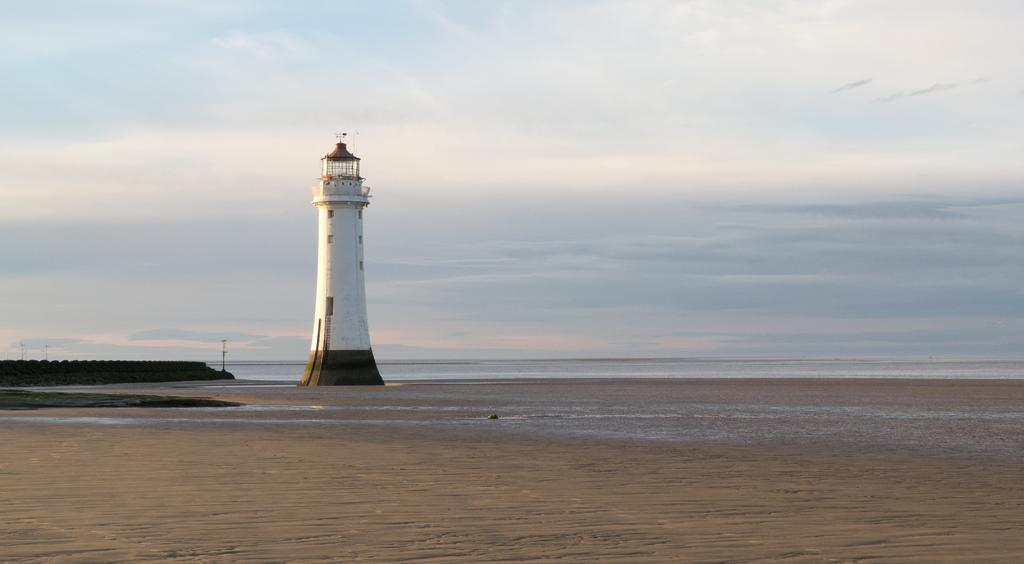What is the main subject of the picture? The main subject of the picture is a lighthouse. Can you describe the appearance of the lighthouse? The lighthouse is white. What type of terrain is visible on the left side of the image? There is sand on the left side of the image. What body of water is visible on the right side of the image? There is an ocean on the right side of the image. How would you describe the weather in the image? The sky is clear, suggesting good weather. Reasoning: Let's think step by step to produce the conversation. We start by mentioning the main subject of the image, which is the lighthouse. Then, we describe its appearance, focusing on the color. Next, we identify the terrain and body of water visible on the sides. Finally, we describe the weather based on the sky's condition. Absurd Question/Answer: What type of disease is affecting the lighthouse in the image? There is no indication of any disease affecting the lighthouse in the image. Can you tell me how many church spires are visible in the image? There are no church spires present in the image; it features a lighthouse and natural elements. 